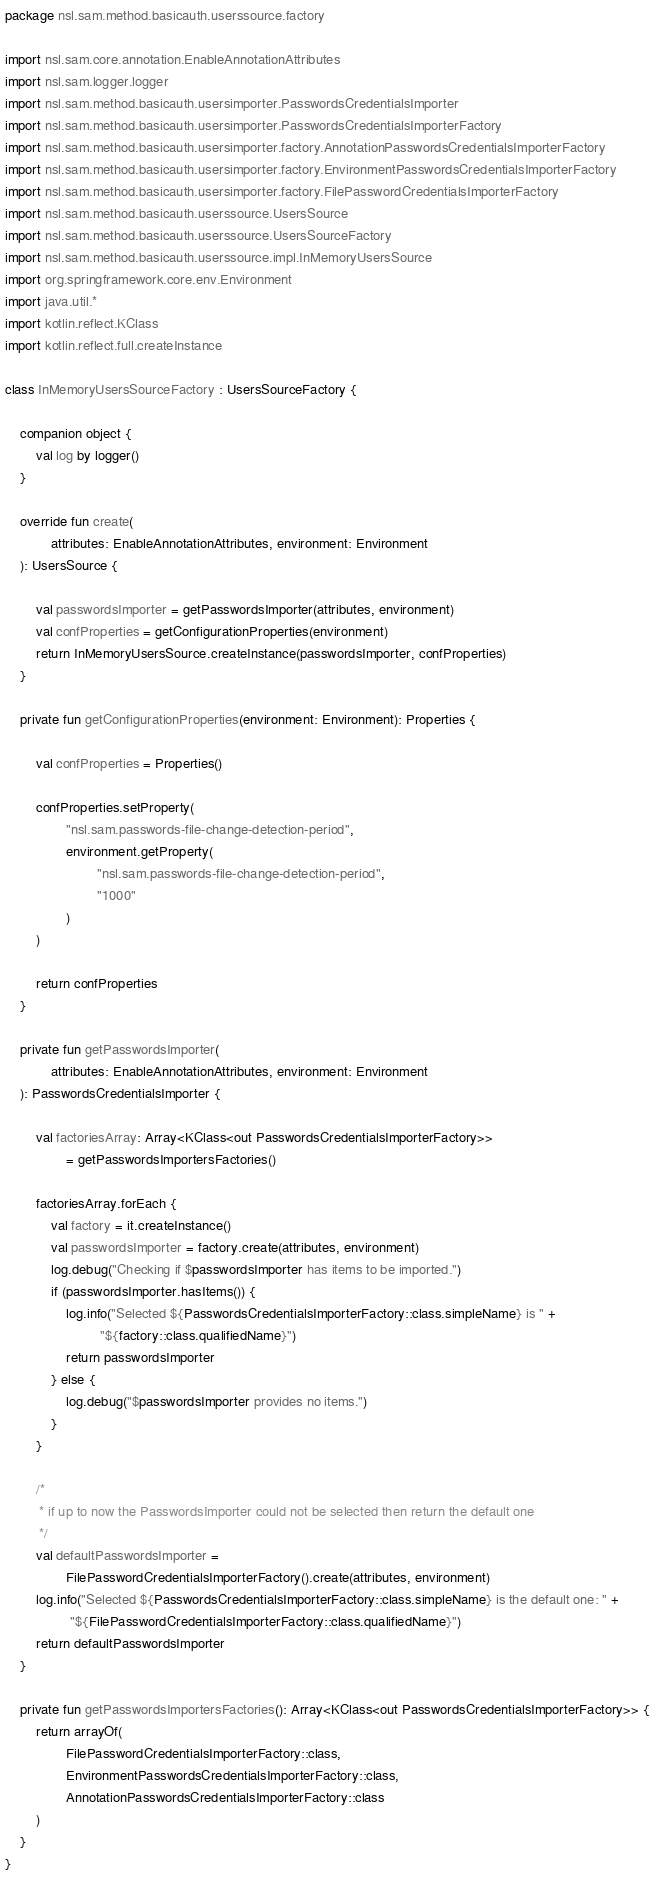Convert code to text. <code><loc_0><loc_0><loc_500><loc_500><_Kotlin_>package nsl.sam.method.basicauth.userssource.factory

import nsl.sam.core.annotation.EnableAnnotationAttributes
import nsl.sam.logger.logger
import nsl.sam.method.basicauth.usersimporter.PasswordsCredentialsImporter
import nsl.sam.method.basicauth.usersimporter.PasswordsCredentialsImporterFactory
import nsl.sam.method.basicauth.usersimporter.factory.AnnotationPasswordsCredentialsImporterFactory
import nsl.sam.method.basicauth.usersimporter.factory.EnvironmentPasswordsCredentialsImporterFactory
import nsl.sam.method.basicauth.usersimporter.factory.FilePasswordCredentialsImporterFactory
import nsl.sam.method.basicauth.userssource.UsersSource
import nsl.sam.method.basicauth.userssource.UsersSourceFactory
import nsl.sam.method.basicauth.userssource.impl.InMemoryUsersSource
import org.springframework.core.env.Environment
import java.util.*
import kotlin.reflect.KClass
import kotlin.reflect.full.createInstance

class InMemoryUsersSourceFactory : UsersSourceFactory {

    companion object {
        val log by logger()
    }

    override fun create(
            attributes: EnableAnnotationAttributes, environment: Environment
    ): UsersSource {

        val passwordsImporter = getPasswordsImporter(attributes, environment)
        val confProperties = getConfigurationProperties(environment)
        return InMemoryUsersSource.createInstance(passwordsImporter, confProperties)
    }

    private fun getConfigurationProperties(environment: Environment): Properties {

        val confProperties = Properties()

        confProperties.setProperty(
                "nsl.sam.passwords-file-change-detection-period",
                environment.getProperty(
                        "nsl.sam.passwords-file-change-detection-period",
                        "1000"
                )
        )

        return confProperties
    }

    private fun getPasswordsImporter(
            attributes: EnableAnnotationAttributes, environment: Environment
    ): PasswordsCredentialsImporter {

        val factoriesArray: Array<KClass<out PasswordsCredentialsImporterFactory>>
                = getPasswordsImportersFactories()

        factoriesArray.forEach {
            val factory = it.createInstance()
            val passwordsImporter = factory.create(attributes, environment)
            log.debug("Checking if $passwordsImporter has items to be imported.")
            if (passwordsImporter.hasItems()) {
                log.info("Selected ${PasswordsCredentialsImporterFactory::class.simpleName} is " +
                         "${factory::class.qualifiedName}")
                return passwordsImporter
            } else {
                log.debug("$passwordsImporter provides no items.")
            }
        }

        /*
         * if up to now the PasswordsImporter could not be selected then return the default one
         */
        val defaultPasswordsImporter =
                FilePasswordCredentialsImporterFactory().create(attributes, environment)
        log.info("Selected ${PasswordsCredentialsImporterFactory::class.simpleName} is the default one: " +
                 "${FilePasswordCredentialsImporterFactory::class.qualifiedName}")
        return defaultPasswordsImporter
    }

    private fun getPasswordsImportersFactories(): Array<KClass<out PasswordsCredentialsImporterFactory>> {
        return arrayOf(
                FilePasswordCredentialsImporterFactory::class,
                EnvironmentPasswordsCredentialsImporterFactory::class,
                AnnotationPasswordsCredentialsImporterFactory::class
        )
    }
}</code> 